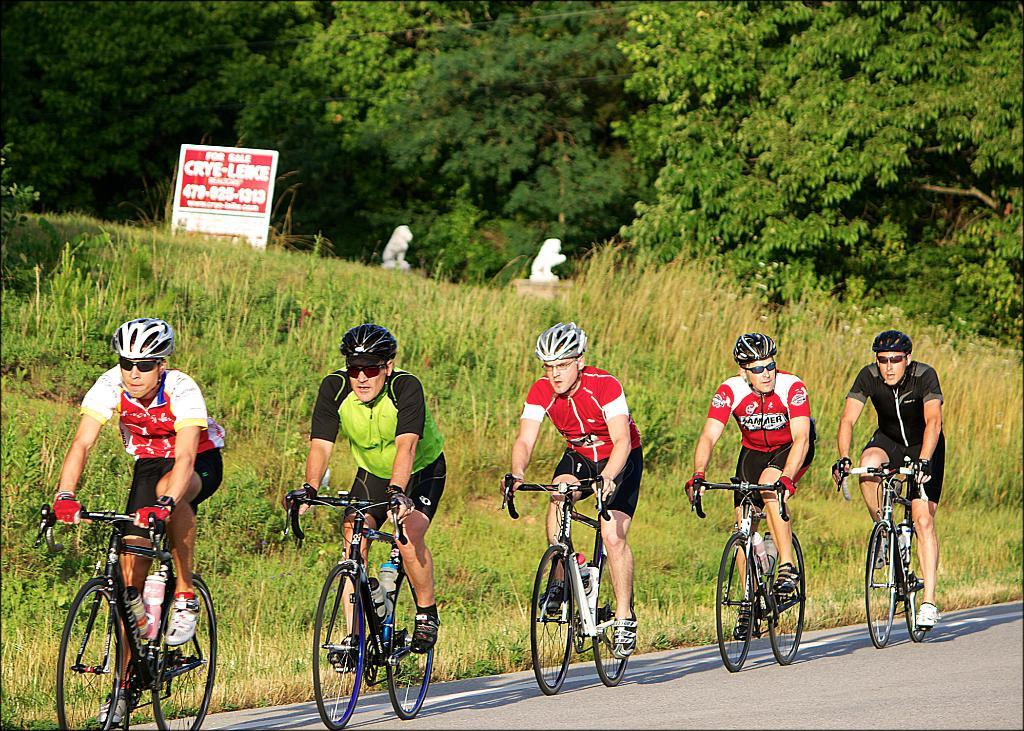What are the people in the image doing? The people in the image are cycling on a road. What can be seen in the background of the image? There are trees, grass, and a board with text in the background of the image. What type of force is being applied by the elbow in the image? There is no elbow present in the image, so it is not possible to determine what type of force might be applied. 